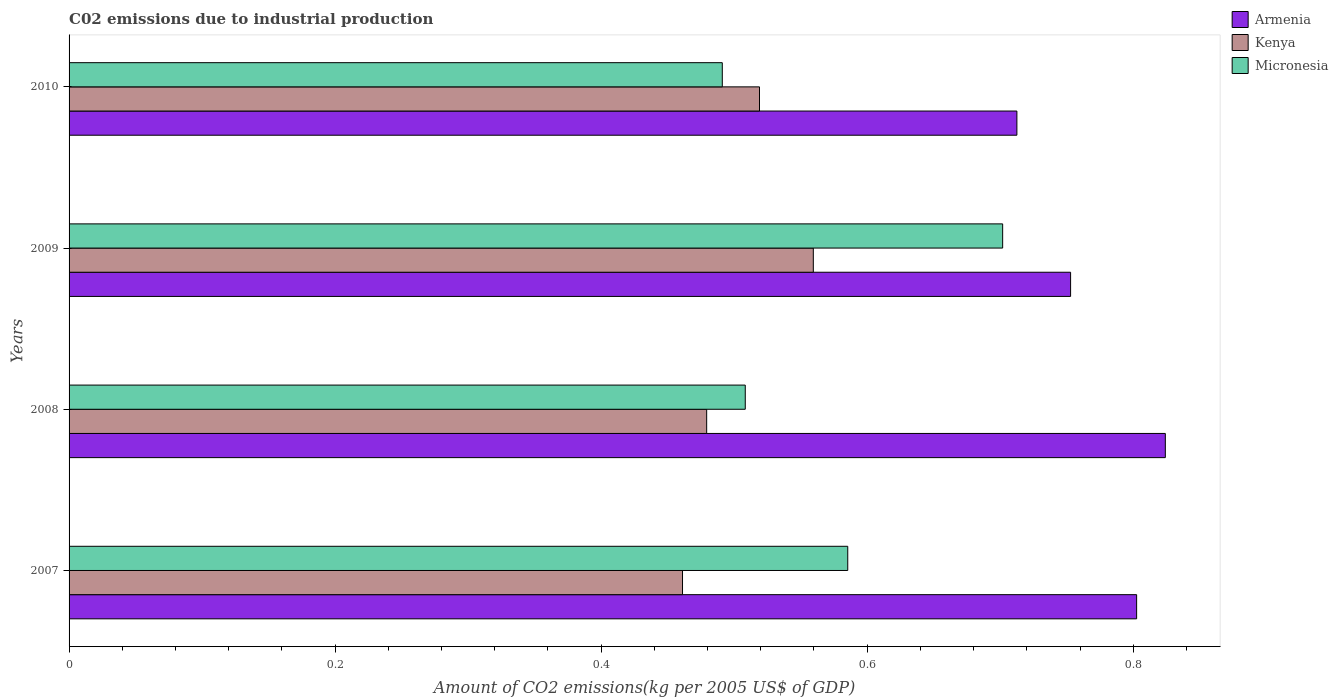How many different coloured bars are there?
Offer a very short reply. 3. Are the number of bars per tick equal to the number of legend labels?
Offer a terse response. Yes. Are the number of bars on each tick of the Y-axis equal?
Keep it short and to the point. Yes. In how many cases, is the number of bars for a given year not equal to the number of legend labels?
Make the answer very short. 0. What is the amount of CO2 emitted due to industrial production in Micronesia in 2009?
Your answer should be very brief. 0.7. Across all years, what is the maximum amount of CO2 emitted due to industrial production in Kenya?
Your answer should be very brief. 0.56. Across all years, what is the minimum amount of CO2 emitted due to industrial production in Micronesia?
Your answer should be compact. 0.49. In which year was the amount of CO2 emitted due to industrial production in Armenia minimum?
Keep it short and to the point. 2010. What is the total amount of CO2 emitted due to industrial production in Armenia in the graph?
Keep it short and to the point. 3.09. What is the difference between the amount of CO2 emitted due to industrial production in Armenia in 2008 and that in 2010?
Provide a short and direct response. 0.11. What is the difference between the amount of CO2 emitted due to industrial production in Kenya in 2009 and the amount of CO2 emitted due to industrial production in Micronesia in 2008?
Ensure brevity in your answer.  0.05. What is the average amount of CO2 emitted due to industrial production in Micronesia per year?
Make the answer very short. 0.57. In the year 2007, what is the difference between the amount of CO2 emitted due to industrial production in Kenya and amount of CO2 emitted due to industrial production in Micronesia?
Your response must be concise. -0.12. In how many years, is the amount of CO2 emitted due to industrial production in Kenya greater than 0.7600000000000001 kg?
Your response must be concise. 0. What is the ratio of the amount of CO2 emitted due to industrial production in Micronesia in 2009 to that in 2010?
Make the answer very short. 1.43. Is the amount of CO2 emitted due to industrial production in Kenya in 2007 less than that in 2009?
Provide a short and direct response. Yes. What is the difference between the highest and the second highest amount of CO2 emitted due to industrial production in Micronesia?
Ensure brevity in your answer.  0.12. What is the difference between the highest and the lowest amount of CO2 emitted due to industrial production in Kenya?
Your response must be concise. 0.1. Is the sum of the amount of CO2 emitted due to industrial production in Armenia in 2007 and 2008 greater than the maximum amount of CO2 emitted due to industrial production in Kenya across all years?
Your answer should be compact. Yes. What does the 1st bar from the top in 2007 represents?
Offer a terse response. Micronesia. What does the 3rd bar from the bottom in 2007 represents?
Provide a short and direct response. Micronesia. Are all the bars in the graph horizontal?
Your response must be concise. Yes. Are the values on the major ticks of X-axis written in scientific E-notation?
Keep it short and to the point. No. Where does the legend appear in the graph?
Ensure brevity in your answer.  Top right. How are the legend labels stacked?
Your answer should be compact. Vertical. What is the title of the graph?
Provide a succinct answer. C02 emissions due to industrial production. What is the label or title of the X-axis?
Give a very brief answer. Amount of CO2 emissions(kg per 2005 US$ of GDP). What is the Amount of CO2 emissions(kg per 2005 US$ of GDP) in Armenia in 2007?
Your response must be concise. 0.8. What is the Amount of CO2 emissions(kg per 2005 US$ of GDP) of Kenya in 2007?
Your response must be concise. 0.46. What is the Amount of CO2 emissions(kg per 2005 US$ of GDP) in Micronesia in 2007?
Your answer should be very brief. 0.59. What is the Amount of CO2 emissions(kg per 2005 US$ of GDP) in Armenia in 2008?
Ensure brevity in your answer.  0.82. What is the Amount of CO2 emissions(kg per 2005 US$ of GDP) of Kenya in 2008?
Your answer should be very brief. 0.48. What is the Amount of CO2 emissions(kg per 2005 US$ of GDP) of Micronesia in 2008?
Make the answer very short. 0.51. What is the Amount of CO2 emissions(kg per 2005 US$ of GDP) of Armenia in 2009?
Provide a succinct answer. 0.75. What is the Amount of CO2 emissions(kg per 2005 US$ of GDP) in Kenya in 2009?
Your answer should be very brief. 0.56. What is the Amount of CO2 emissions(kg per 2005 US$ of GDP) in Micronesia in 2009?
Offer a terse response. 0.7. What is the Amount of CO2 emissions(kg per 2005 US$ of GDP) in Armenia in 2010?
Your answer should be compact. 0.71. What is the Amount of CO2 emissions(kg per 2005 US$ of GDP) in Kenya in 2010?
Offer a terse response. 0.52. What is the Amount of CO2 emissions(kg per 2005 US$ of GDP) of Micronesia in 2010?
Your answer should be compact. 0.49. Across all years, what is the maximum Amount of CO2 emissions(kg per 2005 US$ of GDP) in Armenia?
Offer a very short reply. 0.82. Across all years, what is the maximum Amount of CO2 emissions(kg per 2005 US$ of GDP) of Kenya?
Your answer should be very brief. 0.56. Across all years, what is the maximum Amount of CO2 emissions(kg per 2005 US$ of GDP) in Micronesia?
Keep it short and to the point. 0.7. Across all years, what is the minimum Amount of CO2 emissions(kg per 2005 US$ of GDP) in Armenia?
Give a very brief answer. 0.71. Across all years, what is the minimum Amount of CO2 emissions(kg per 2005 US$ of GDP) in Kenya?
Your answer should be compact. 0.46. Across all years, what is the minimum Amount of CO2 emissions(kg per 2005 US$ of GDP) in Micronesia?
Ensure brevity in your answer.  0.49. What is the total Amount of CO2 emissions(kg per 2005 US$ of GDP) of Armenia in the graph?
Your answer should be compact. 3.09. What is the total Amount of CO2 emissions(kg per 2005 US$ of GDP) of Kenya in the graph?
Keep it short and to the point. 2.02. What is the total Amount of CO2 emissions(kg per 2005 US$ of GDP) of Micronesia in the graph?
Keep it short and to the point. 2.29. What is the difference between the Amount of CO2 emissions(kg per 2005 US$ of GDP) in Armenia in 2007 and that in 2008?
Ensure brevity in your answer.  -0.02. What is the difference between the Amount of CO2 emissions(kg per 2005 US$ of GDP) in Kenya in 2007 and that in 2008?
Give a very brief answer. -0.02. What is the difference between the Amount of CO2 emissions(kg per 2005 US$ of GDP) of Micronesia in 2007 and that in 2008?
Your response must be concise. 0.08. What is the difference between the Amount of CO2 emissions(kg per 2005 US$ of GDP) of Armenia in 2007 and that in 2009?
Provide a succinct answer. 0.05. What is the difference between the Amount of CO2 emissions(kg per 2005 US$ of GDP) in Kenya in 2007 and that in 2009?
Provide a short and direct response. -0.1. What is the difference between the Amount of CO2 emissions(kg per 2005 US$ of GDP) of Micronesia in 2007 and that in 2009?
Provide a succinct answer. -0.12. What is the difference between the Amount of CO2 emissions(kg per 2005 US$ of GDP) of Armenia in 2007 and that in 2010?
Give a very brief answer. 0.09. What is the difference between the Amount of CO2 emissions(kg per 2005 US$ of GDP) in Kenya in 2007 and that in 2010?
Make the answer very short. -0.06. What is the difference between the Amount of CO2 emissions(kg per 2005 US$ of GDP) in Micronesia in 2007 and that in 2010?
Keep it short and to the point. 0.09. What is the difference between the Amount of CO2 emissions(kg per 2005 US$ of GDP) of Armenia in 2008 and that in 2009?
Your response must be concise. 0.07. What is the difference between the Amount of CO2 emissions(kg per 2005 US$ of GDP) in Kenya in 2008 and that in 2009?
Make the answer very short. -0.08. What is the difference between the Amount of CO2 emissions(kg per 2005 US$ of GDP) of Micronesia in 2008 and that in 2009?
Ensure brevity in your answer.  -0.19. What is the difference between the Amount of CO2 emissions(kg per 2005 US$ of GDP) of Armenia in 2008 and that in 2010?
Provide a short and direct response. 0.11. What is the difference between the Amount of CO2 emissions(kg per 2005 US$ of GDP) of Kenya in 2008 and that in 2010?
Offer a terse response. -0.04. What is the difference between the Amount of CO2 emissions(kg per 2005 US$ of GDP) of Micronesia in 2008 and that in 2010?
Your response must be concise. 0.02. What is the difference between the Amount of CO2 emissions(kg per 2005 US$ of GDP) in Armenia in 2009 and that in 2010?
Your answer should be very brief. 0.04. What is the difference between the Amount of CO2 emissions(kg per 2005 US$ of GDP) in Kenya in 2009 and that in 2010?
Provide a succinct answer. 0.04. What is the difference between the Amount of CO2 emissions(kg per 2005 US$ of GDP) of Micronesia in 2009 and that in 2010?
Offer a very short reply. 0.21. What is the difference between the Amount of CO2 emissions(kg per 2005 US$ of GDP) of Armenia in 2007 and the Amount of CO2 emissions(kg per 2005 US$ of GDP) of Kenya in 2008?
Make the answer very short. 0.32. What is the difference between the Amount of CO2 emissions(kg per 2005 US$ of GDP) of Armenia in 2007 and the Amount of CO2 emissions(kg per 2005 US$ of GDP) of Micronesia in 2008?
Offer a very short reply. 0.29. What is the difference between the Amount of CO2 emissions(kg per 2005 US$ of GDP) of Kenya in 2007 and the Amount of CO2 emissions(kg per 2005 US$ of GDP) of Micronesia in 2008?
Your response must be concise. -0.05. What is the difference between the Amount of CO2 emissions(kg per 2005 US$ of GDP) in Armenia in 2007 and the Amount of CO2 emissions(kg per 2005 US$ of GDP) in Kenya in 2009?
Offer a terse response. 0.24. What is the difference between the Amount of CO2 emissions(kg per 2005 US$ of GDP) of Armenia in 2007 and the Amount of CO2 emissions(kg per 2005 US$ of GDP) of Micronesia in 2009?
Your answer should be compact. 0.1. What is the difference between the Amount of CO2 emissions(kg per 2005 US$ of GDP) of Kenya in 2007 and the Amount of CO2 emissions(kg per 2005 US$ of GDP) of Micronesia in 2009?
Your response must be concise. -0.24. What is the difference between the Amount of CO2 emissions(kg per 2005 US$ of GDP) of Armenia in 2007 and the Amount of CO2 emissions(kg per 2005 US$ of GDP) of Kenya in 2010?
Your response must be concise. 0.28. What is the difference between the Amount of CO2 emissions(kg per 2005 US$ of GDP) of Armenia in 2007 and the Amount of CO2 emissions(kg per 2005 US$ of GDP) of Micronesia in 2010?
Your answer should be very brief. 0.31. What is the difference between the Amount of CO2 emissions(kg per 2005 US$ of GDP) in Kenya in 2007 and the Amount of CO2 emissions(kg per 2005 US$ of GDP) in Micronesia in 2010?
Your answer should be compact. -0.03. What is the difference between the Amount of CO2 emissions(kg per 2005 US$ of GDP) of Armenia in 2008 and the Amount of CO2 emissions(kg per 2005 US$ of GDP) of Kenya in 2009?
Offer a very short reply. 0.26. What is the difference between the Amount of CO2 emissions(kg per 2005 US$ of GDP) of Armenia in 2008 and the Amount of CO2 emissions(kg per 2005 US$ of GDP) of Micronesia in 2009?
Provide a succinct answer. 0.12. What is the difference between the Amount of CO2 emissions(kg per 2005 US$ of GDP) in Kenya in 2008 and the Amount of CO2 emissions(kg per 2005 US$ of GDP) in Micronesia in 2009?
Offer a terse response. -0.22. What is the difference between the Amount of CO2 emissions(kg per 2005 US$ of GDP) of Armenia in 2008 and the Amount of CO2 emissions(kg per 2005 US$ of GDP) of Kenya in 2010?
Make the answer very short. 0.31. What is the difference between the Amount of CO2 emissions(kg per 2005 US$ of GDP) of Armenia in 2008 and the Amount of CO2 emissions(kg per 2005 US$ of GDP) of Micronesia in 2010?
Keep it short and to the point. 0.33. What is the difference between the Amount of CO2 emissions(kg per 2005 US$ of GDP) of Kenya in 2008 and the Amount of CO2 emissions(kg per 2005 US$ of GDP) of Micronesia in 2010?
Ensure brevity in your answer.  -0.01. What is the difference between the Amount of CO2 emissions(kg per 2005 US$ of GDP) in Armenia in 2009 and the Amount of CO2 emissions(kg per 2005 US$ of GDP) in Kenya in 2010?
Provide a succinct answer. 0.23. What is the difference between the Amount of CO2 emissions(kg per 2005 US$ of GDP) in Armenia in 2009 and the Amount of CO2 emissions(kg per 2005 US$ of GDP) in Micronesia in 2010?
Offer a very short reply. 0.26. What is the difference between the Amount of CO2 emissions(kg per 2005 US$ of GDP) of Kenya in 2009 and the Amount of CO2 emissions(kg per 2005 US$ of GDP) of Micronesia in 2010?
Provide a succinct answer. 0.07. What is the average Amount of CO2 emissions(kg per 2005 US$ of GDP) of Armenia per year?
Give a very brief answer. 0.77. What is the average Amount of CO2 emissions(kg per 2005 US$ of GDP) of Kenya per year?
Your answer should be compact. 0.5. What is the average Amount of CO2 emissions(kg per 2005 US$ of GDP) of Micronesia per year?
Offer a very short reply. 0.57. In the year 2007, what is the difference between the Amount of CO2 emissions(kg per 2005 US$ of GDP) in Armenia and Amount of CO2 emissions(kg per 2005 US$ of GDP) in Kenya?
Make the answer very short. 0.34. In the year 2007, what is the difference between the Amount of CO2 emissions(kg per 2005 US$ of GDP) in Armenia and Amount of CO2 emissions(kg per 2005 US$ of GDP) in Micronesia?
Give a very brief answer. 0.22. In the year 2007, what is the difference between the Amount of CO2 emissions(kg per 2005 US$ of GDP) of Kenya and Amount of CO2 emissions(kg per 2005 US$ of GDP) of Micronesia?
Your answer should be compact. -0.12. In the year 2008, what is the difference between the Amount of CO2 emissions(kg per 2005 US$ of GDP) in Armenia and Amount of CO2 emissions(kg per 2005 US$ of GDP) in Kenya?
Provide a succinct answer. 0.34. In the year 2008, what is the difference between the Amount of CO2 emissions(kg per 2005 US$ of GDP) of Armenia and Amount of CO2 emissions(kg per 2005 US$ of GDP) of Micronesia?
Make the answer very short. 0.32. In the year 2008, what is the difference between the Amount of CO2 emissions(kg per 2005 US$ of GDP) of Kenya and Amount of CO2 emissions(kg per 2005 US$ of GDP) of Micronesia?
Give a very brief answer. -0.03. In the year 2009, what is the difference between the Amount of CO2 emissions(kg per 2005 US$ of GDP) in Armenia and Amount of CO2 emissions(kg per 2005 US$ of GDP) in Kenya?
Provide a succinct answer. 0.19. In the year 2009, what is the difference between the Amount of CO2 emissions(kg per 2005 US$ of GDP) of Armenia and Amount of CO2 emissions(kg per 2005 US$ of GDP) of Micronesia?
Offer a very short reply. 0.05. In the year 2009, what is the difference between the Amount of CO2 emissions(kg per 2005 US$ of GDP) in Kenya and Amount of CO2 emissions(kg per 2005 US$ of GDP) in Micronesia?
Make the answer very short. -0.14. In the year 2010, what is the difference between the Amount of CO2 emissions(kg per 2005 US$ of GDP) in Armenia and Amount of CO2 emissions(kg per 2005 US$ of GDP) in Kenya?
Your answer should be very brief. 0.19. In the year 2010, what is the difference between the Amount of CO2 emissions(kg per 2005 US$ of GDP) of Armenia and Amount of CO2 emissions(kg per 2005 US$ of GDP) of Micronesia?
Keep it short and to the point. 0.22. In the year 2010, what is the difference between the Amount of CO2 emissions(kg per 2005 US$ of GDP) in Kenya and Amount of CO2 emissions(kg per 2005 US$ of GDP) in Micronesia?
Keep it short and to the point. 0.03. What is the ratio of the Amount of CO2 emissions(kg per 2005 US$ of GDP) in Armenia in 2007 to that in 2008?
Your response must be concise. 0.97. What is the ratio of the Amount of CO2 emissions(kg per 2005 US$ of GDP) of Kenya in 2007 to that in 2008?
Provide a succinct answer. 0.96. What is the ratio of the Amount of CO2 emissions(kg per 2005 US$ of GDP) in Micronesia in 2007 to that in 2008?
Provide a succinct answer. 1.15. What is the ratio of the Amount of CO2 emissions(kg per 2005 US$ of GDP) in Armenia in 2007 to that in 2009?
Your answer should be compact. 1.07. What is the ratio of the Amount of CO2 emissions(kg per 2005 US$ of GDP) in Kenya in 2007 to that in 2009?
Your answer should be compact. 0.82. What is the ratio of the Amount of CO2 emissions(kg per 2005 US$ of GDP) in Micronesia in 2007 to that in 2009?
Keep it short and to the point. 0.83. What is the ratio of the Amount of CO2 emissions(kg per 2005 US$ of GDP) of Armenia in 2007 to that in 2010?
Your answer should be compact. 1.13. What is the ratio of the Amount of CO2 emissions(kg per 2005 US$ of GDP) in Kenya in 2007 to that in 2010?
Offer a very short reply. 0.89. What is the ratio of the Amount of CO2 emissions(kg per 2005 US$ of GDP) in Micronesia in 2007 to that in 2010?
Provide a short and direct response. 1.19. What is the ratio of the Amount of CO2 emissions(kg per 2005 US$ of GDP) in Armenia in 2008 to that in 2009?
Offer a very short reply. 1.09. What is the ratio of the Amount of CO2 emissions(kg per 2005 US$ of GDP) of Kenya in 2008 to that in 2009?
Give a very brief answer. 0.86. What is the ratio of the Amount of CO2 emissions(kg per 2005 US$ of GDP) of Micronesia in 2008 to that in 2009?
Ensure brevity in your answer.  0.72. What is the ratio of the Amount of CO2 emissions(kg per 2005 US$ of GDP) of Armenia in 2008 to that in 2010?
Your answer should be compact. 1.16. What is the ratio of the Amount of CO2 emissions(kg per 2005 US$ of GDP) in Kenya in 2008 to that in 2010?
Provide a short and direct response. 0.92. What is the ratio of the Amount of CO2 emissions(kg per 2005 US$ of GDP) in Micronesia in 2008 to that in 2010?
Your answer should be very brief. 1.04. What is the ratio of the Amount of CO2 emissions(kg per 2005 US$ of GDP) in Armenia in 2009 to that in 2010?
Offer a terse response. 1.06. What is the ratio of the Amount of CO2 emissions(kg per 2005 US$ of GDP) of Kenya in 2009 to that in 2010?
Ensure brevity in your answer.  1.08. What is the ratio of the Amount of CO2 emissions(kg per 2005 US$ of GDP) of Micronesia in 2009 to that in 2010?
Make the answer very short. 1.43. What is the difference between the highest and the second highest Amount of CO2 emissions(kg per 2005 US$ of GDP) of Armenia?
Offer a terse response. 0.02. What is the difference between the highest and the second highest Amount of CO2 emissions(kg per 2005 US$ of GDP) in Kenya?
Provide a succinct answer. 0.04. What is the difference between the highest and the second highest Amount of CO2 emissions(kg per 2005 US$ of GDP) of Micronesia?
Make the answer very short. 0.12. What is the difference between the highest and the lowest Amount of CO2 emissions(kg per 2005 US$ of GDP) in Armenia?
Ensure brevity in your answer.  0.11. What is the difference between the highest and the lowest Amount of CO2 emissions(kg per 2005 US$ of GDP) of Kenya?
Keep it short and to the point. 0.1. What is the difference between the highest and the lowest Amount of CO2 emissions(kg per 2005 US$ of GDP) in Micronesia?
Offer a terse response. 0.21. 